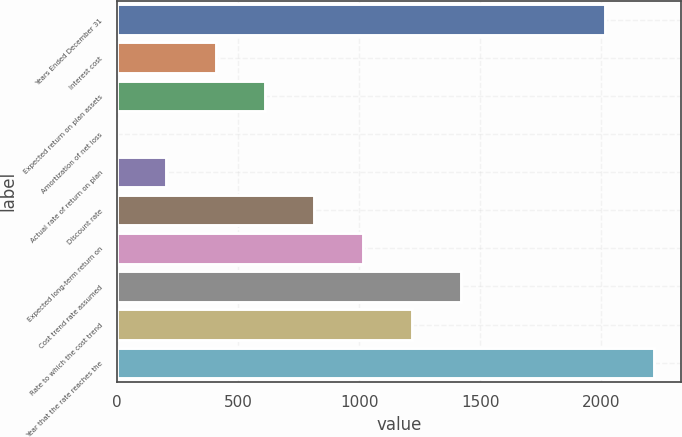<chart> <loc_0><loc_0><loc_500><loc_500><bar_chart><fcel>Years Ended December 31<fcel>Interest cost<fcel>Expected return on plan assets<fcel>Amortization of net loss<fcel>Actual rate of return on plan<fcel>Discount rate<fcel>Expected long-term return on<fcel>Cost trend rate assumed<fcel>Rate to which the cost trend<fcel>Year that the rate reaches the<nl><fcel>2016<fcel>406.2<fcel>608.8<fcel>1<fcel>203.6<fcel>811.4<fcel>1014<fcel>1419.2<fcel>1216.6<fcel>2218.6<nl></chart> 